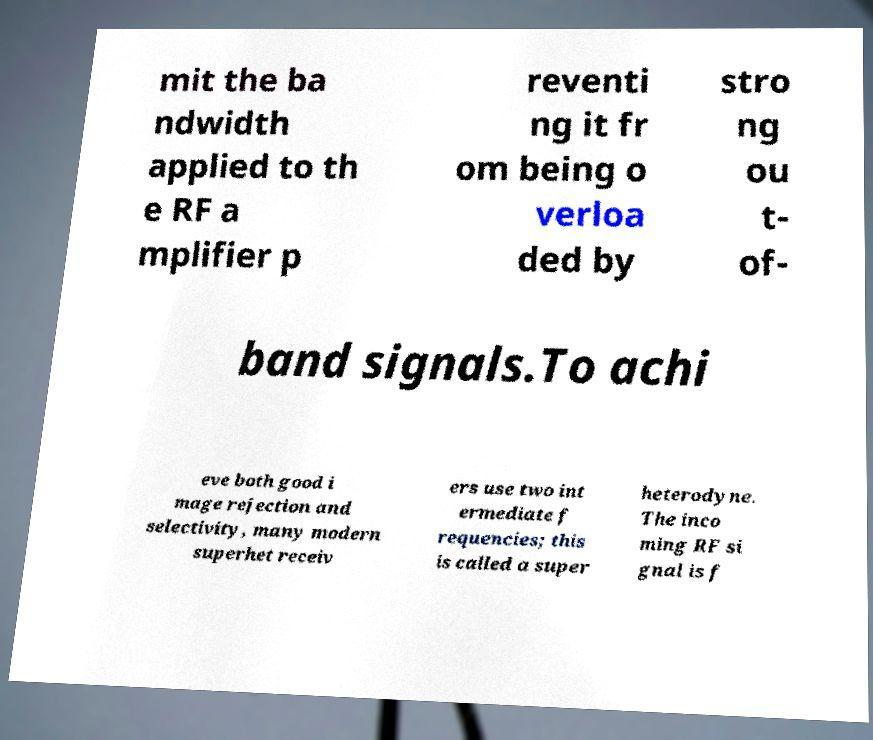Can you read and provide the text displayed in the image?This photo seems to have some interesting text. Can you extract and type it out for me? mit the ba ndwidth applied to th e RF a mplifier p reventi ng it fr om being o verloa ded by stro ng ou t- of- band signals.To achi eve both good i mage rejection and selectivity, many modern superhet receiv ers use two int ermediate f requencies; this is called a super heterodyne. The inco ming RF si gnal is f 